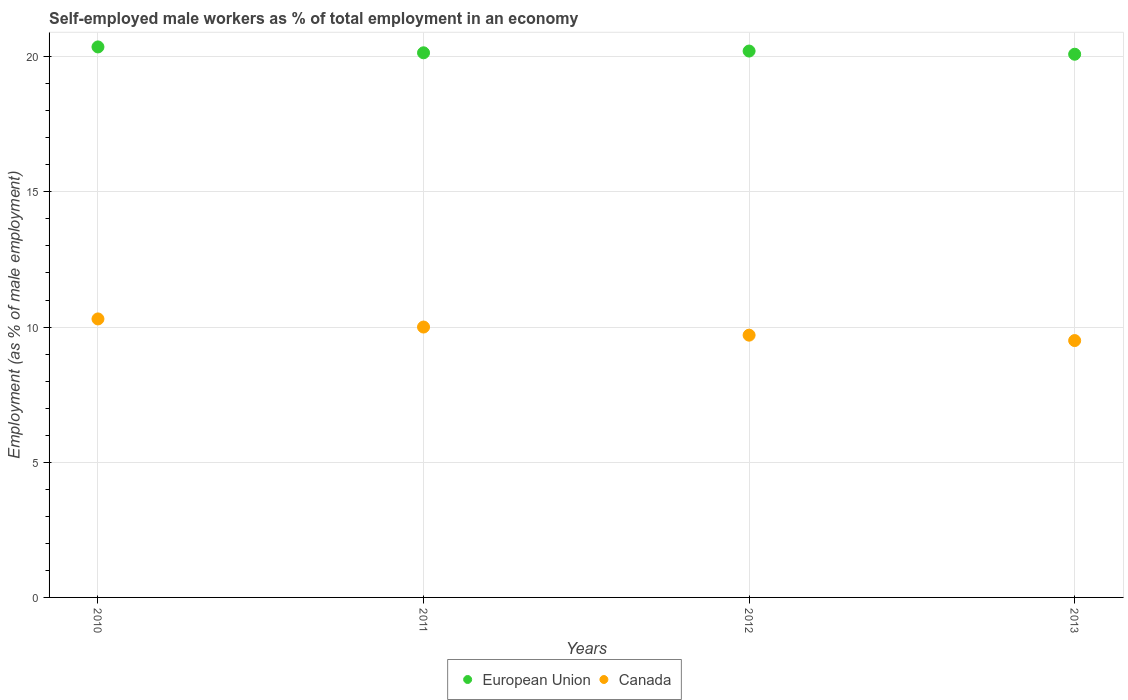How many different coloured dotlines are there?
Your response must be concise. 2. What is the percentage of self-employed male workers in European Union in 2013?
Ensure brevity in your answer.  20.09. Across all years, what is the maximum percentage of self-employed male workers in European Union?
Give a very brief answer. 20.36. Across all years, what is the minimum percentage of self-employed male workers in Canada?
Your response must be concise. 9.5. In which year was the percentage of self-employed male workers in Canada minimum?
Provide a short and direct response. 2013. What is the total percentage of self-employed male workers in Canada in the graph?
Provide a succinct answer. 39.5. What is the difference between the percentage of self-employed male workers in European Union in 2010 and that in 2011?
Give a very brief answer. 0.22. What is the difference between the percentage of self-employed male workers in European Union in 2011 and the percentage of self-employed male workers in Canada in 2012?
Your answer should be compact. 10.44. What is the average percentage of self-employed male workers in Canada per year?
Keep it short and to the point. 9.88. In the year 2013, what is the difference between the percentage of self-employed male workers in European Union and percentage of self-employed male workers in Canada?
Provide a short and direct response. 10.59. In how many years, is the percentage of self-employed male workers in Canada greater than 18 %?
Make the answer very short. 0. What is the ratio of the percentage of self-employed male workers in European Union in 2010 to that in 2013?
Give a very brief answer. 1.01. Is the percentage of self-employed male workers in European Union in 2012 less than that in 2013?
Offer a very short reply. No. What is the difference between the highest and the second highest percentage of self-employed male workers in European Union?
Your answer should be compact. 0.15. What is the difference between the highest and the lowest percentage of self-employed male workers in European Union?
Ensure brevity in your answer.  0.27. Is the sum of the percentage of self-employed male workers in European Union in 2010 and 2013 greater than the maximum percentage of self-employed male workers in Canada across all years?
Your answer should be compact. Yes. Does the percentage of self-employed male workers in European Union monotonically increase over the years?
Your answer should be compact. No. How many years are there in the graph?
Provide a succinct answer. 4. What is the difference between two consecutive major ticks on the Y-axis?
Ensure brevity in your answer.  5. Are the values on the major ticks of Y-axis written in scientific E-notation?
Your answer should be very brief. No. Does the graph contain any zero values?
Your response must be concise. No. Does the graph contain grids?
Make the answer very short. Yes. How many legend labels are there?
Provide a short and direct response. 2. What is the title of the graph?
Provide a succinct answer. Self-employed male workers as % of total employment in an economy. Does "East Asia (all income levels)" appear as one of the legend labels in the graph?
Your response must be concise. No. What is the label or title of the Y-axis?
Your answer should be compact. Employment (as % of male employment). What is the Employment (as % of male employment) in European Union in 2010?
Give a very brief answer. 20.36. What is the Employment (as % of male employment) in Canada in 2010?
Provide a short and direct response. 10.3. What is the Employment (as % of male employment) of European Union in 2011?
Your answer should be very brief. 20.14. What is the Employment (as % of male employment) in European Union in 2012?
Provide a succinct answer. 20.21. What is the Employment (as % of male employment) in Canada in 2012?
Your answer should be compact. 9.7. What is the Employment (as % of male employment) of European Union in 2013?
Offer a terse response. 20.09. Across all years, what is the maximum Employment (as % of male employment) in European Union?
Offer a very short reply. 20.36. Across all years, what is the maximum Employment (as % of male employment) in Canada?
Your answer should be very brief. 10.3. Across all years, what is the minimum Employment (as % of male employment) in European Union?
Keep it short and to the point. 20.09. Across all years, what is the minimum Employment (as % of male employment) of Canada?
Your answer should be very brief. 9.5. What is the total Employment (as % of male employment) of European Union in the graph?
Offer a terse response. 80.8. What is the total Employment (as % of male employment) in Canada in the graph?
Your answer should be compact. 39.5. What is the difference between the Employment (as % of male employment) of European Union in 2010 and that in 2011?
Your response must be concise. 0.22. What is the difference between the Employment (as % of male employment) of Canada in 2010 and that in 2011?
Ensure brevity in your answer.  0.3. What is the difference between the Employment (as % of male employment) in European Union in 2010 and that in 2012?
Provide a succinct answer. 0.15. What is the difference between the Employment (as % of male employment) in European Union in 2010 and that in 2013?
Provide a short and direct response. 0.27. What is the difference between the Employment (as % of male employment) of Canada in 2010 and that in 2013?
Your answer should be compact. 0.8. What is the difference between the Employment (as % of male employment) in European Union in 2011 and that in 2012?
Give a very brief answer. -0.06. What is the difference between the Employment (as % of male employment) of Canada in 2011 and that in 2012?
Provide a succinct answer. 0.3. What is the difference between the Employment (as % of male employment) of European Union in 2011 and that in 2013?
Offer a terse response. 0.05. What is the difference between the Employment (as % of male employment) of Canada in 2011 and that in 2013?
Ensure brevity in your answer.  0.5. What is the difference between the Employment (as % of male employment) in European Union in 2012 and that in 2013?
Your response must be concise. 0.12. What is the difference between the Employment (as % of male employment) of European Union in 2010 and the Employment (as % of male employment) of Canada in 2011?
Ensure brevity in your answer.  10.36. What is the difference between the Employment (as % of male employment) of European Union in 2010 and the Employment (as % of male employment) of Canada in 2012?
Ensure brevity in your answer.  10.66. What is the difference between the Employment (as % of male employment) of European Union in 2010 and the Employment (as % of male employment) of Canada in 2013?
Provide a short and direct response. 10.86. What is the difference between the Employment (as % of male employment) of European Union in 2011 and the Employment (as % of male employment) of Canada in 2012?
Offer a very short reply. 10.44. What is the difference between the Employment (as % of male employment) of European Union in 2011 and the Employment (as % of male employment) of Canada in 2013?
Offer a very short reply. 10.64. What is the difference between the Employment (as % of male employment) in European Union in 2012 and the Employment (as % of male employment) in Canada in 2013?
Keep it short and to the point. 10.71. What is the average Employment (as % of male employment) of European Union per year?
Keep it short and to the point. 20.2. What is the average Employment (as % of male employment) in Canada per year?
Offer a very short reply. 9.88. In the year 2010, what is the difference between the Employment (as % of male employment) in European Union and Employment (as % of male employment) in Canada?
Make the answer very short. 10.06. In the year 2011, what is the difference between the Employment (as % of male employment) of European Union and Employment (as % of male employment) of Canada?
Provide a short and direct response. 10.14. In the year 2012, what is the difference between the Employment (as % of male employment) in European Union and Employment (as % of male employment) in Canada?
Ensure brevity in your answer.  10.51. In the year 2013, what is the difference between the Employment (as % of male employment) of European Union and Employment (as % of male employment) of Canada?
Offer a terse response. 10.59. What is the ratio of the Employment (as % of male employment) of European Union in 2010 to that in 2011?
Make the answer very short. 1.01. What is the ratio of the Employment (as % of male employment) in European Union in 2010 to that in 2012?
Give a very brief answer. 1.01. What is the ratio of the Employment (as % of male employment) in Canada in 2010 to that in 2012?
Keep it short and to the point. 1.06. What is the ratio of the Employment (as % of male employment) in European Union in 2010 to that in 2013?
Your answer should be very brief. 1.01. What is the ratio of the Employment (as % of male employment) of Canada in 2010 to that in 2013?
Provide a short and direct response. 1.08. What is the ratio of the Employment (as % of male employment) of Canada in 2011 to that in 2012?
Ensure brevity in your answer.  1.03. What is the ratio of the Employment (as % of male employment) of European Union in 2011 to that in 2013?
Provide a succinct answer. 1. What is the ratio of the Employment (as % of male employment) in Canada in 2011 to that in 2013?
Provide a succinct answer. 1.05. What is the ratio of the Employment (as % of male employment) of European Union in 2012 to that in 2013?
Provide a short and direct response. 1.01. What is the ratio of the Employment (as % of male employment) in Canada in 2012 to that in 2013?
Keep it short and to the point. 1.02. What is the difference between the highest and the second highest Employment (as % of male employment) in European Union?
Your response must be concise. 0.15. What is the difference between the highest and the lowest Employment (as % of male employment) in European Union?
Make the answer very short. 0.27. What is the difference between the highest and the lowest Employment (as % of male employment) of Canada?
Provide a succinct answer. 0.8. 